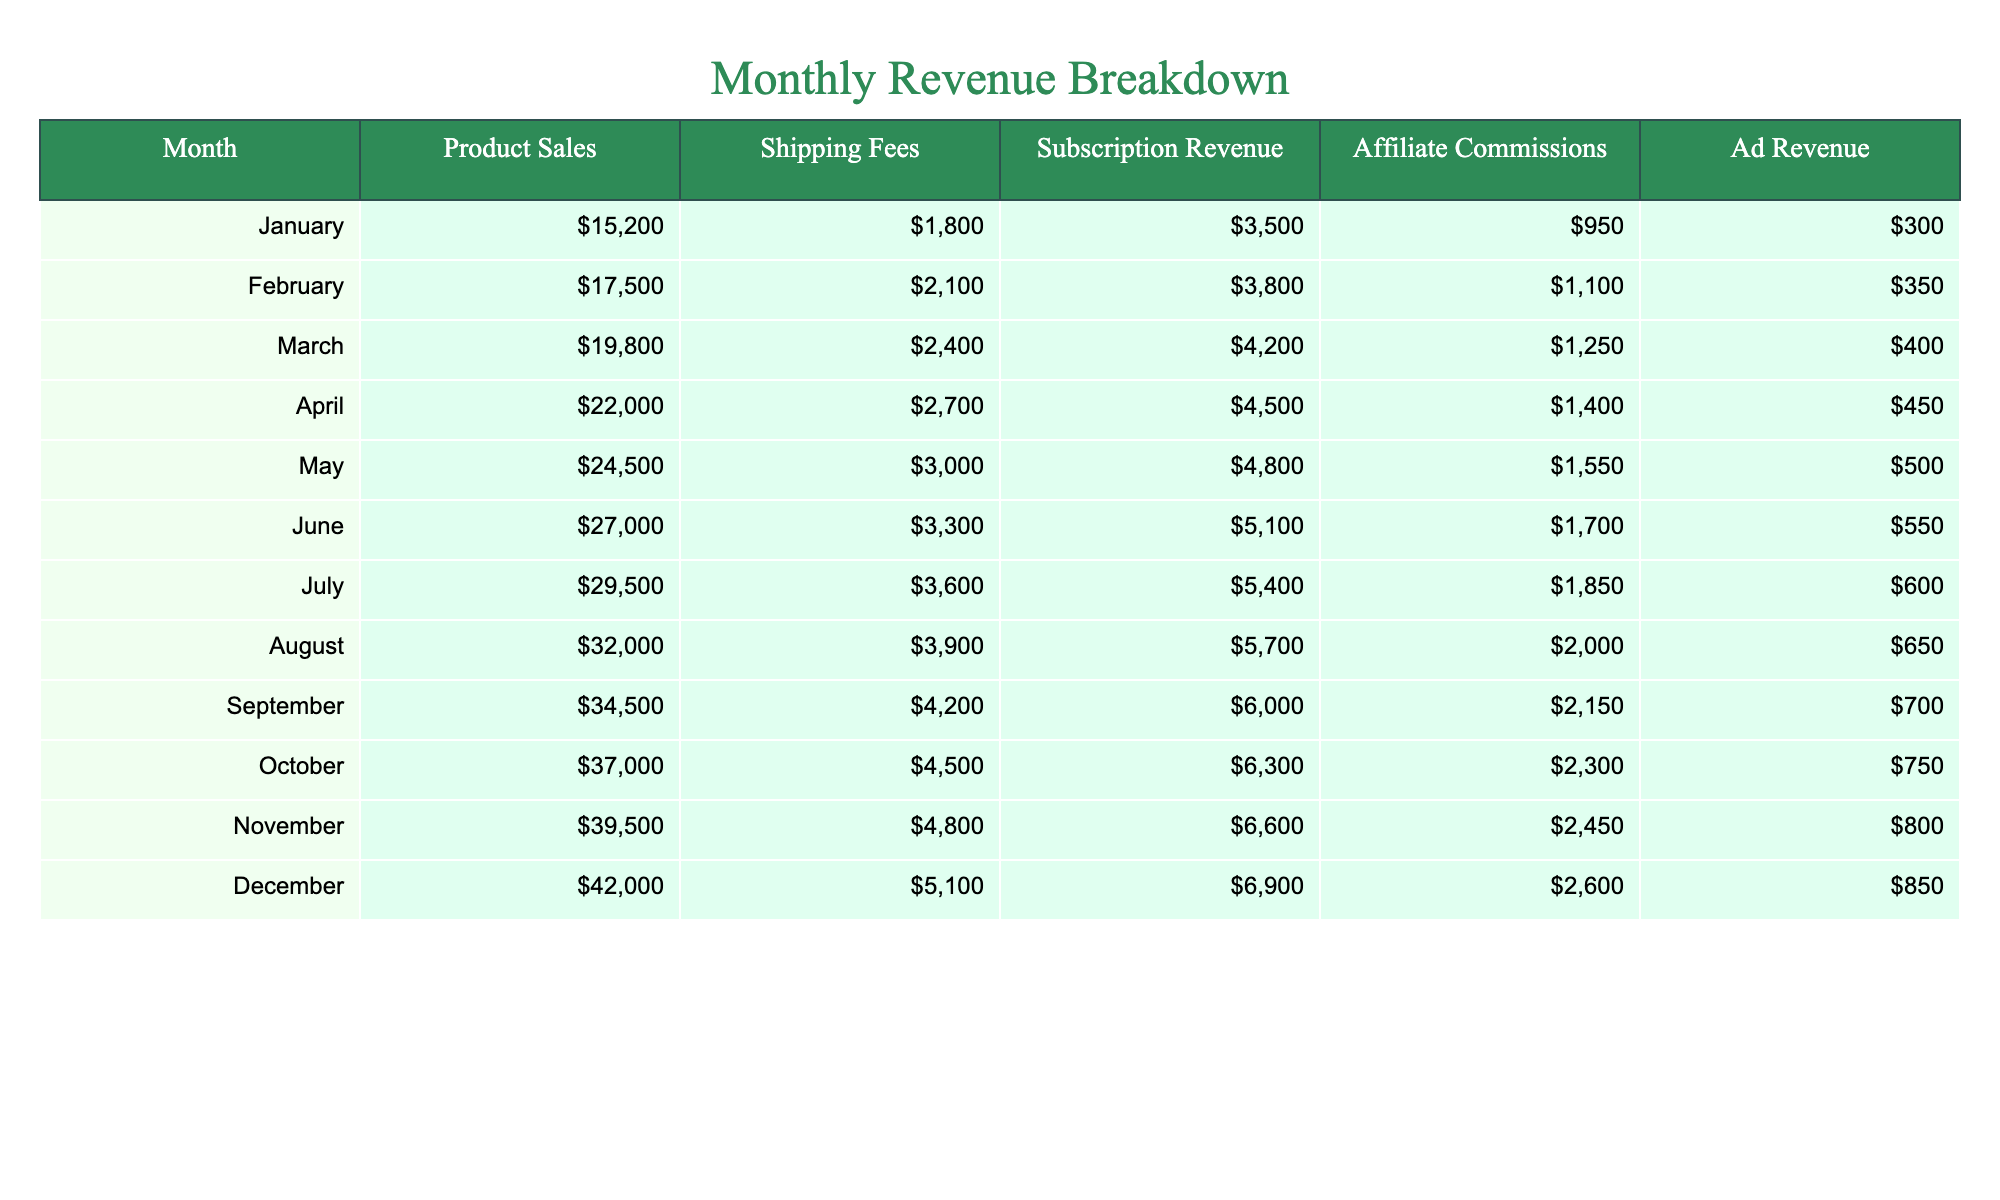What was the total revenue from Product Sales in March? In March, the revenue from Product Sales is directly stated in the table as 19,800.
Answer: 19,800 What is the highest revenue for Affiliate Commissions in a month? Looking through the Affiliate Commissions column, December has the highest revenue listed, which is 2,600.
Answer: 2,600 What is the average Shipping Fees over the 12 months? The total shipping fees from all months is 36,300 (1,800 + 2,100 + 2,400 + 2,700 + 3,000 + 3,300 + 3,600 + 3,900 + 4,200 + 4,500 + 4,800 + 5,100 = 36,300), and dividing by 12 months gives an average of 3,025.
Answer: 3,025 In which month did the Subscription Revenue first surpass 5,000? Looking at the Subscription Revenue values, it first exceeds 5,000 in July (5,400) after being below that amount in the previous months.
Answer: July What is the difference in total revenue between Product Sales in December and January? The revenue from Product Sales in December is 42,000, and in January it is 15,200. The difference is 42,000 - 15,200 = 26,800.
Answer: 26,800 Is the Ad Revenue in November greater than the average Ad Revenue for the year? The Ad Revenue for November is 800. The total Ad Revenue for the year is 5,850, and dividing that by 12 gives an average of 487.5. Since 800 is greater than 487.5, the statement is true.
Answer: Yes What is the sum of all revenue categories in October? The total for October can be calculated by adding all values: Product Sales (37,000) + Shipping Fees (4,500) + Subscription Revenue (6,300) + Affiliate Commissions (2,300) + Ad Revenue (750) = 50,850.
Answer: 50,850 Which month had the highest total revenue across all categories? By calculating the total revenue for each month and comparing them, December has the highest total (42,000 + 5,100 + 6,900 + 2,600 + 850 = 57,550).
Answer: December Has the shipping fee increased every month compared to the previous month? By checking the Shipping Fees column, it’s evident that each month has a higher shipping fee than the one before, confirming that it has indeed increased consistently.
Answer: Yes What was the percentage increase in Product Sales from January to December? The increase in Product Sales from January (15,200) to December (42,000) is 42,000 - 15,200 = 26,800. To calculate the percentage increase, divide 26,800 by 15,200 and multiply by 100, resulting in approximately 176.32%.
Answer: 176.32% 